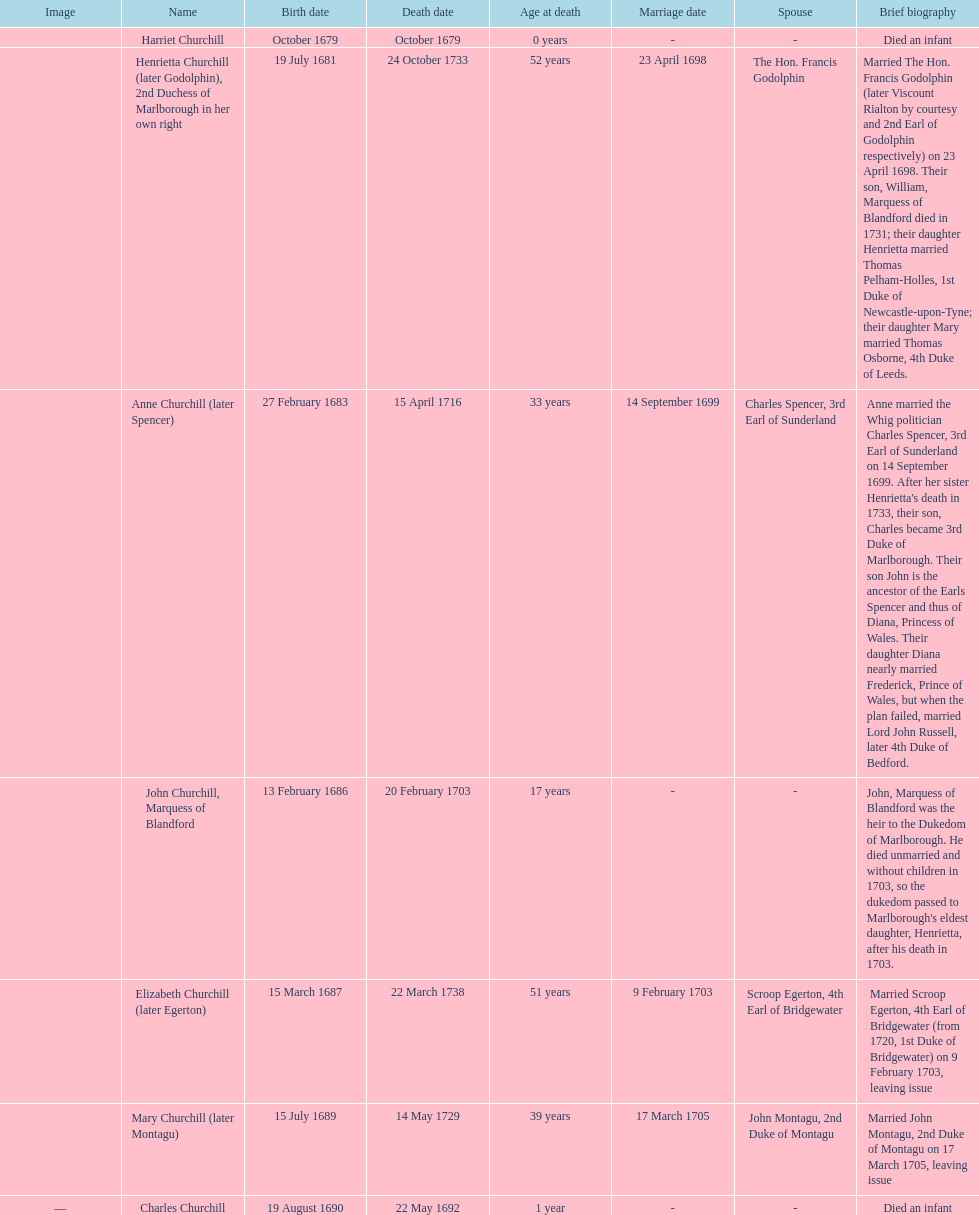What is the total number of children born after 1675? 7. 